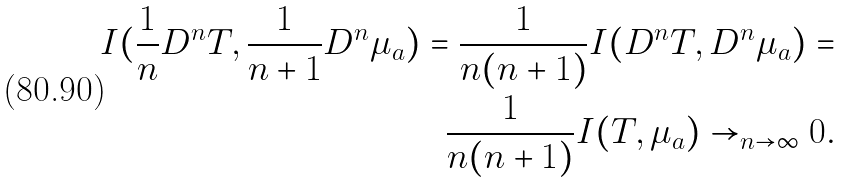<formula> <loc_0><loc_0><loc_500><loc_500>I ( \frac { 1 } { n } D ^ { n } T , \frac { 1 } { n + 1 } D ^ { n } \mu _ { a } ) = \frac { 1 } { n ( n + 1 ) } I ( D ^ { n } T , D ^ { n } \mu _ { a } ) = \\ \frac { 1 } { n ( n + 1 ) } I ( T , \mu _ { a } ) \to _ { n \to \infty } 0 .</formula> 